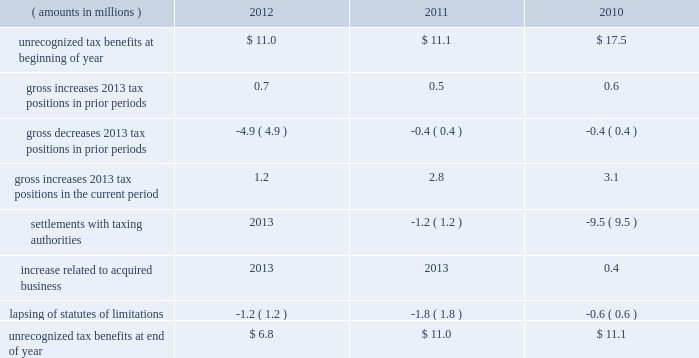A valuation allowance totaling $ 43.9 million , $ 40.4 million and $ 40.1 million as of 2012 , 2011 and 2010 year end , respectively , has been established for deferred income tax assets primarily related to certain subsidiary loss carryforwards that may not be realized .
Realization of the net deferred income tax assets is dependent on generating sufficient taxable income prior to their expiration .
Although realization is not assured , management believes it is more- likely-than-not that the net deferred income tax assets will be realized .
The amount of the net deferred income tax assets considered realizable , however , could change in the near term if estimates of future taxable income during the carryforward period fluctuate .
The following is a reconciliation of the beginning and ending amounts of unrecognized tax benefits for 2012 , 2011 and ( amounts in millions ) 2012 2011 2010 .
Of the $ 6.8 million , $ 11.0 million and $ 11.1 million of unrecognized tax benefits as of 2012 , 2011 and 2010 year end , respectively , approximately $ 4.1 million , $ 9.1 million and $ 11.1 million , respectively , would impact the effective income tax rate if recognized .
Interest and penalties related to unrecognized tax benefits are recorded in income tax expense .
During 2012 and 2011 , the company reversed a net $ 0.5 million and $ 1.4 million , respectively , of interest and penalties to income associated with unrecognized tax benefits .
As of 2012 , 2011 and 2010 year end , the company has provided for $ 1.6 million , $ 1.6 million and $ 2.8 million , respectively , of accrued interest and penalties related to unrecognized tax benefits .
The unrecognized tax benefits and related accrued interest and penalties are included in 201cother long-term liabilities 201d on the accompanying consolidated balance sheets .
Snap-on and its subsidiaries file income tax returns in the united states and in various state , local and foreign jurisdictions .
It is reasonably possible that certain unrecognized tax benefits may either be settled with taxing authorities or the statutes of limitations for such items may lapse within the next 12 months , causing snap-on 2019s gross unrecognized tax benefits to decrease by a range of zero to $ 2.4 million .
Over the next 12 months , snap-on anticipates taking uncertain tax positions on various tax returns for which the related tax benefit does not meet the recognition threshold .
Accordingly , snap-on 2019s gross unrecognized tax benefits may increase by a range of zero to $ 1.6 million over the next 12 months for uncertain tax positions expected to be taken in future tax filings .
With few exceptions , snap-on is no longer subject to u.s .
Federal and state/local income tax examinations by tax authorities for years prior to 2008 , and snap-on is no longer subject to non-u.s .
Income tax examinations by tax authorities for years prior to 2006 .
The undistributed earnings of all non-u.s .
Subsidiaries totaled $ 492.2 million , $ 416.4 million and $ 386.5 million as of 2012 , 2011 and 2010 year end , respectively .
Snap-on has not provided any deferred taxes on these undistributed earnings as it considers the undistributed earnings to be permanently invested .
Determination of the amount of unrecognized deferred income tax liability related to these earnings is not practicable .
2012 annual report 83 .
What is the net change in unrecognized tax benefits in 2012? 
Computations: (6.8 - 11.0)
Answer: -4.2. A valuation allowance totaling $ 43.9 million , $ 40.4 million and $ 40.1 million as of 2012 , 2011 and 2010 year end , respectively , has been established for deferred income tax assets primarily related to certain subsidiary loss carryforwards that may not be realized .
Realization of the net deferred income tax assets is dependent on generating sufficient taxable income prior to their expiration .
Although realization is not assured , management believes it is more- likely-than-not that the net deferred income tax assets will be realized .
The amount of the net deferred income tax assets considered realizable , however , could change in the near term if estimates of future taxable income during the carryforward period fluctuate .
The following is a reconciliation of the beginning and ending amounts of unrecognized tax benefits for 2012 , 2011 and ( amounts in millions ) 2012 2011 2010 .
Of the $ 6.8 million , $ 11.0 million and $ 11.1 million of unrecognized tax benefits as of 2012 , 2011 and 2010 year end , respectively , approximately $ 4.1 million , $ 9.1 million and $ 11.1 million , respectively , would impact the effective income tax rate if recognized .
Interest and penalties related to unrecognized tax benefits are recorded in income tax expense .
During 2012 and 2011 , the company reversed a net $ 0.5 million and $ 1.4 million , respectively , of interest and penalties to income associated with unrecognized tax benefits .
As of 2012 , 2011 and 2010 year end , the company has provided for $ 1.6 million , $ 1.6 million and $ 2.8 million , respectively , of accrued interest and penalties related to unrecognized tax benefits .
The unrecognized tax benefits and related accrued interest and penalties are included in 201cother long-term liabilities 201d on the accompanying consolidated balance sheets .
Snap-on and its subsidiaries file income tax returns in the united states and in various state , local and foreign jurisdictions .
It is reasonably possible that certain unrecognized tax benefits may either be settled with taxing authorities or the statutes of limitations for such items may lapse within the next 12 months , causing snap-on 2019s gross unrecognized tax benefits to decrease by a range of zero to $ 2.4 million .
Over the next 12 months , snap-on anticipates taking uncertain tax positions on various tax returns for which the related tax benefit does not meet the recognition threshold .
Accordingly , snap-on 2019s gross unrecognized tax benefits may increase by a range of zero to $ 1.6 million over the next 12 months for uncertain tax positions expected to be taken in future tax filings .
With few exceptions , snap-on is no longer subject to u.s .
Federal and state/local income tax examinations by tax authorities for years prior to 2008 , and snap-on is no longer subject to non-u.s .
Income tax examinations by tax authorities for years prior to 2006 .
The undistributed earnings of all non-u.s .
Subsidiaries totaled $ 492.2 million , $ 416.4 million and $ 386.5 million as of 2012 , 2011 and 2010 year end , respectively .
Snap-on has not provided any deferred taxes on these undistributed earnings as it considers the undistributed earnings to be permanently invested .
Determination of the amount of unrecognized deferred income tax liability related to these earnings is not practicable .
2012 annual report 83 .
What portion of the unrecognized tax benefits as of 2012 would impact the effective income tax rate if recognized? 
Computations: (4.1 / 6.8)
Answer: 0.60294. 